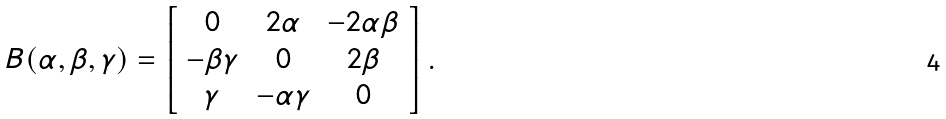Convert formula to latex. <formula><loc_0><loc_0><loc_500><loc_500>B ( \alpha , \beta , \gamma ) = \left [ \begin{array} { c c c } 0 & 2 \alpha & - 2 \alpha \beta \\ - \beta \gamma & 0 & 2 \beta \\ \gamma & - \alpha \gamma & 0 \\ \end{array} \right ] .</formula> 